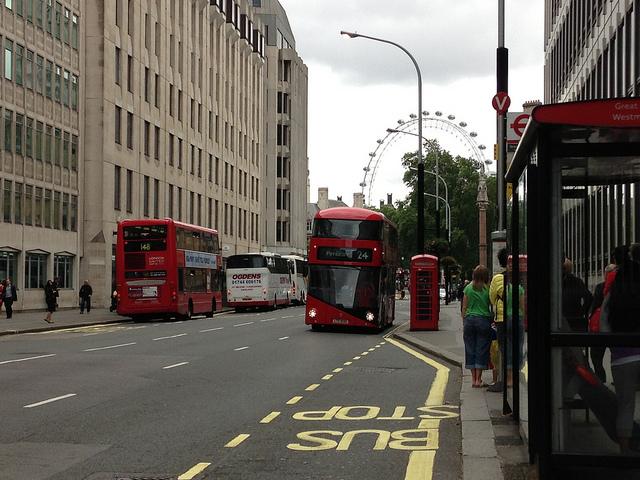What is in the distance of this photo?
Quick response, please. Ferris wheel. What are the yellow stripes on the right?
Be succinct. Bus stop. What color is the closest bus?
Be succinct. Red. Could the man be waiting to use a phone?
Short answer required. No. 